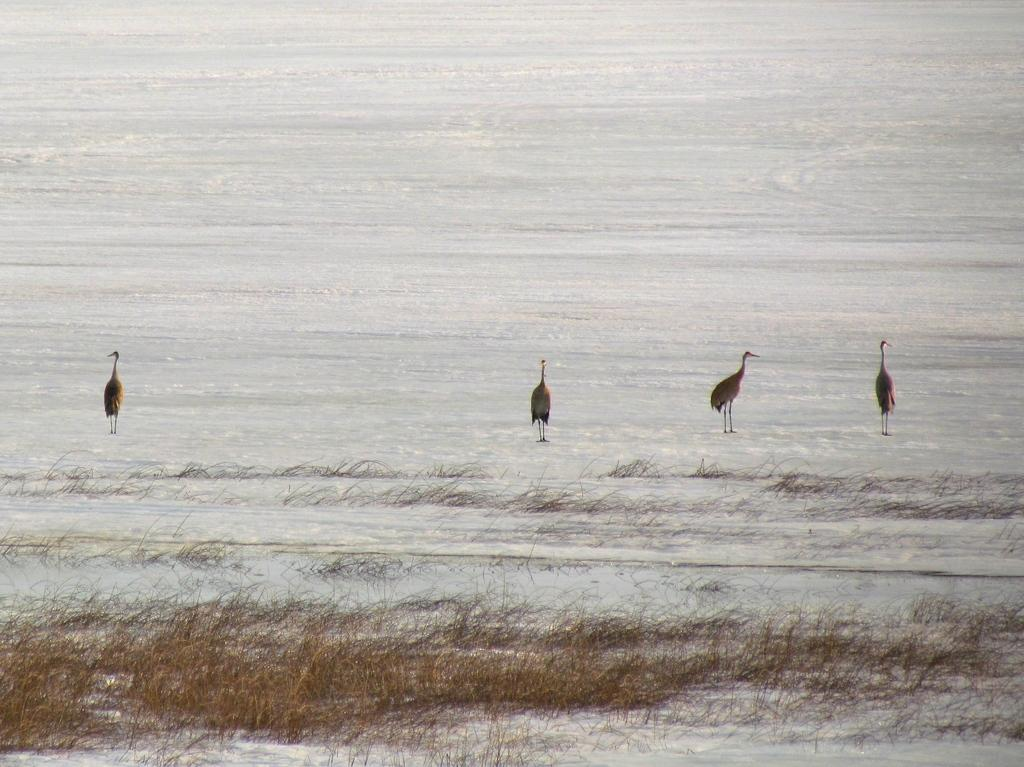What is the condition of the ground in the image? The ground is covered in snow. How many birds are standing on the snow? There are four birds standing on the snow. What type of vegetation can be seen on the ground at the bottom of the image? Grass is visible on the ground at the bottom of the image. What type of horn can be heard in the image? There is no horn present in the image, so no sound can be heard. What is the source of humor in the image? There is no humor depicted in the image; it simply shows four birds standing on snow-covered ground. 